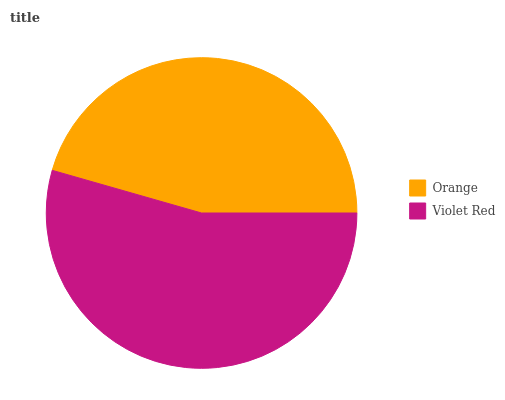Is Orange the minimum?
Answer yes or no. Yes. Is Violet Red the maximum?
Answer yes or no. Yes. Is Violet Red the minimum?
Answer yes or no. No. Is Violet Red greater than Orange?
Answer yes or no. Yes. Is Orange less than Violet Red?
Answer yes or no. Yes. Is Orange greater than Violet Red?
Answer yes or no. No. Is Violet Red less than Orange?
Answer yes or no. No. Is Violet Red the high median?
Answer yes or no. Yes. Is Orange the low median?
Answer yes or no. Yes. Is Orange the high median?
Answer yes or no. No. Is Violet Red the low median?
Answer yes or no. No. 